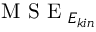<formula> <loc_0><loc_0><loc_500><loc_500>M S E _ { E _ { k i n } }</formula> 